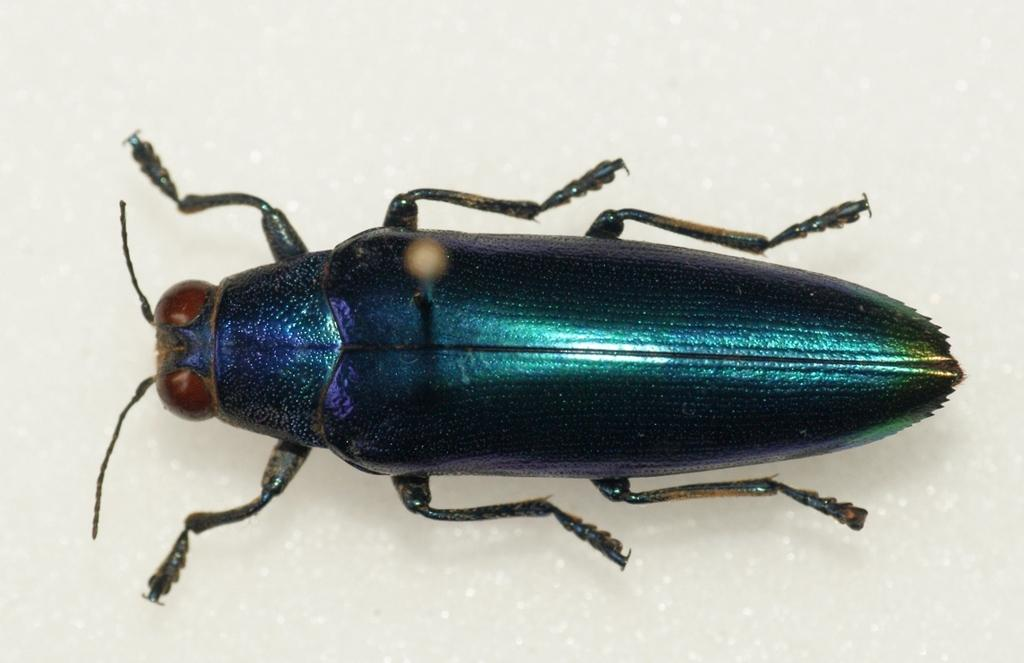What type of creature is in the image? There is an insect in the image. How many legs does the insect have? The insect has six legs. Where is the insect located in the image? The insect is on a white floor. What color is the background of the image? The background of the image is white. What type of sweater is the insect wearing in the image? There is no sweater present in the image, as insects do not wear clothing. 